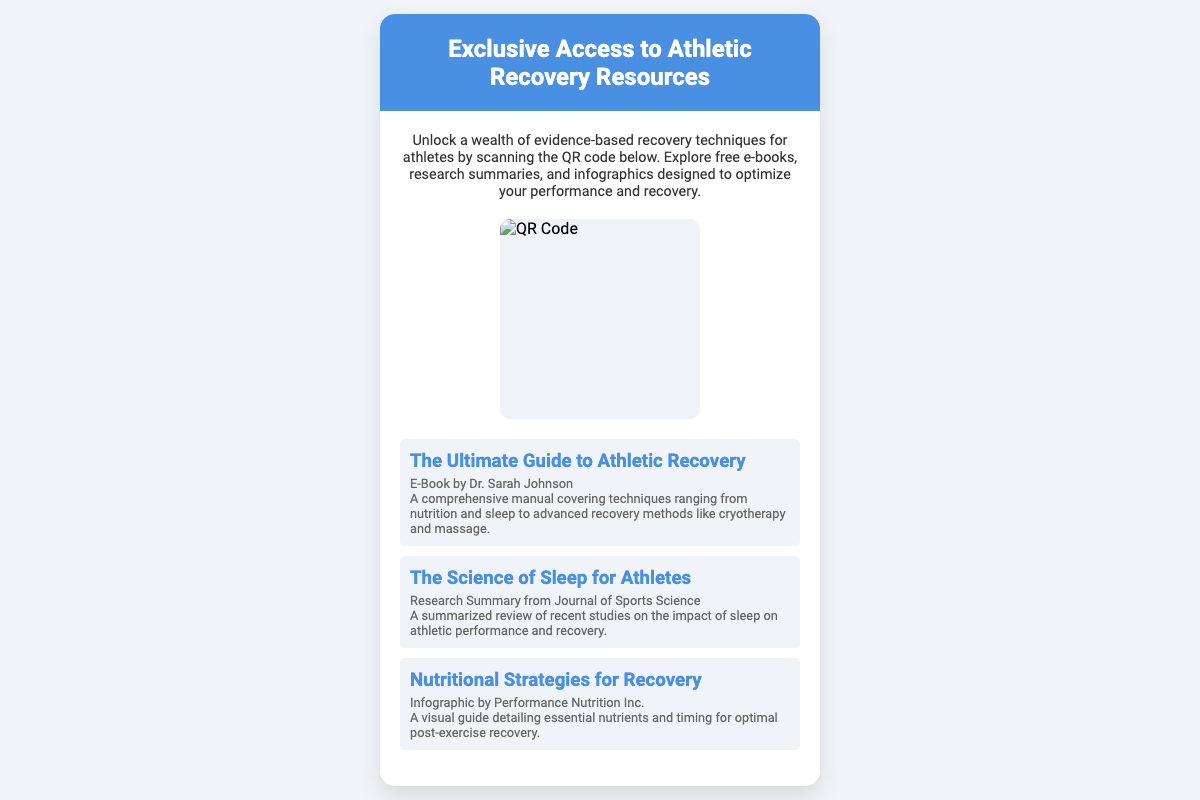What is the title of the document? The title of the document is mentioned at the top of the card, highlighting its focus on athletic recovery resources.
Answer: Exclusive Access to Athletic Recovery Resources Who is the author of "The Ultimate Guide to Athletic Recovery"? The author's name is provided under the title of this e-book, indicating the source of the information presented.
Answer: Dr. Sarah Johnson What is one type of resource available through the QR code? The document lists various resources, and one type is specifically highlighted, demonstrating its offerings.
Answer: E-Book How many resources are listed in the document? The document enumerates the resources, giving a count that reflects the variety available to readers.
Answer: Three What color is the header of the card? The color of the header is clearly stated in the description, setting the tone for the information presented.
Answer: Blue What is the focus of the infographic "Nutritional Strategies for Recovery"? The document describes the content of the infographic, highlighting its key subject matter related to recovery.
Answer: Nutrients and timing What is the primary action encouraged by the document? The document invites the readers to take a specific action to access the resources mentioned.
Answer: Scanning the QR code What does the description emphasize about the resources? The description provides insight into the overall quality and purpose of the resources available, showcasing their importance.
Answer: Evidence-based recovery techniques 